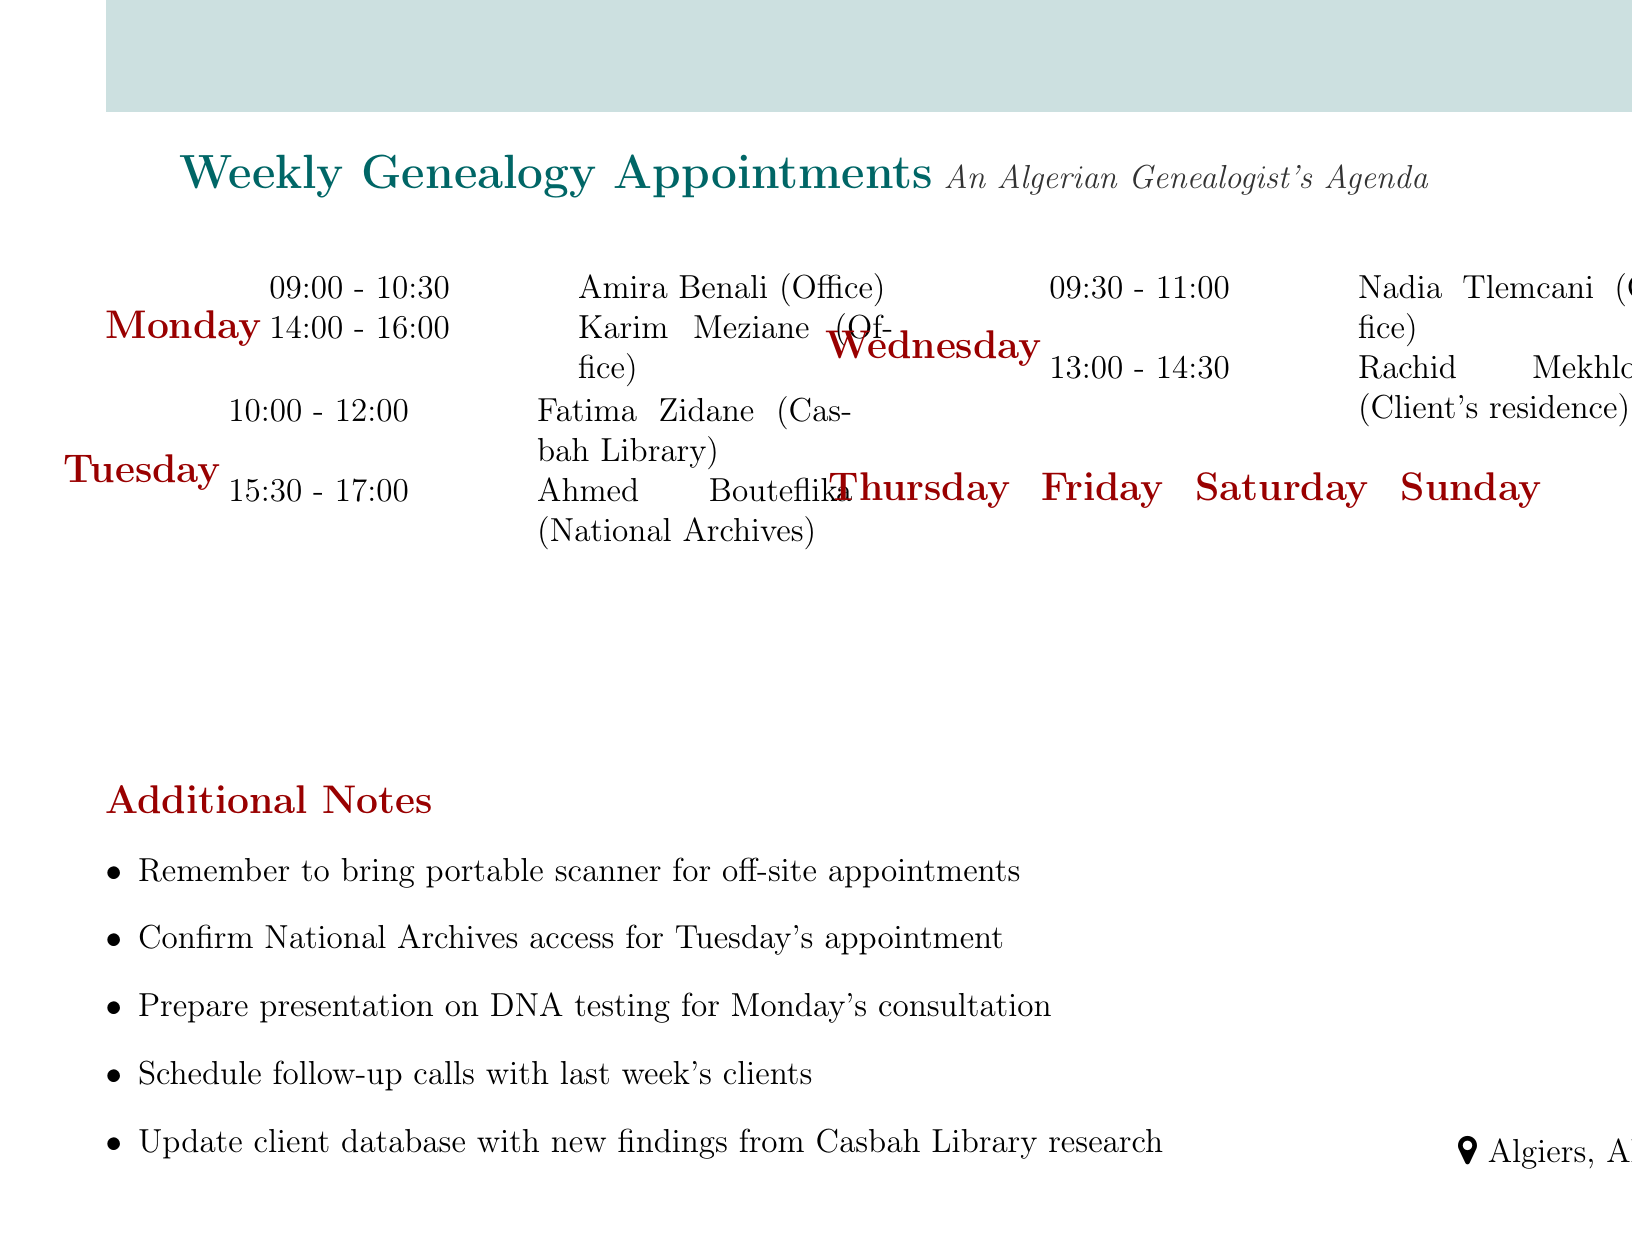What is the appointment time for Amira Benali? The appointment time for Amira Benali is listed under Monday's appointments.
Answer: 09:00 - 10:30 Where does the consultation for Fatima Zidane take place? The location for Fatima Zidane's consultation is specified in Tuesday's appointments.
Answer: Casbah Library, Algiers Who is scheduled for a progress review meeting and at what time? The schedule indicates a progress review meeting in Thursday's appointments.
Answer: Mourad Medelci, 16:00 - 17:30 How many appointments are there on Saturday? The document shows the total number of appointments for Saturday.
Answer: 2 What type of service does Sofiane Feghouli require? The service type is given in Friday's appointments for Sofiane Feghouli.
Answer: Sports lineage investigation Which client has a consultation about political family history? The client seeking consultation about political family history is listed under Sunday’s appointments.
Answer: Louisa Hanoune What is one note to remember for off-site appointments? The additional notes section provides reminders related to appointments.
Answer: Bring portable scanner What day is the appointment for Nadia Tlemcani? The day for Nadia Tlemcani's appointment is mentioned in relation to the schedule of appointments.
Answer: Wednesday 